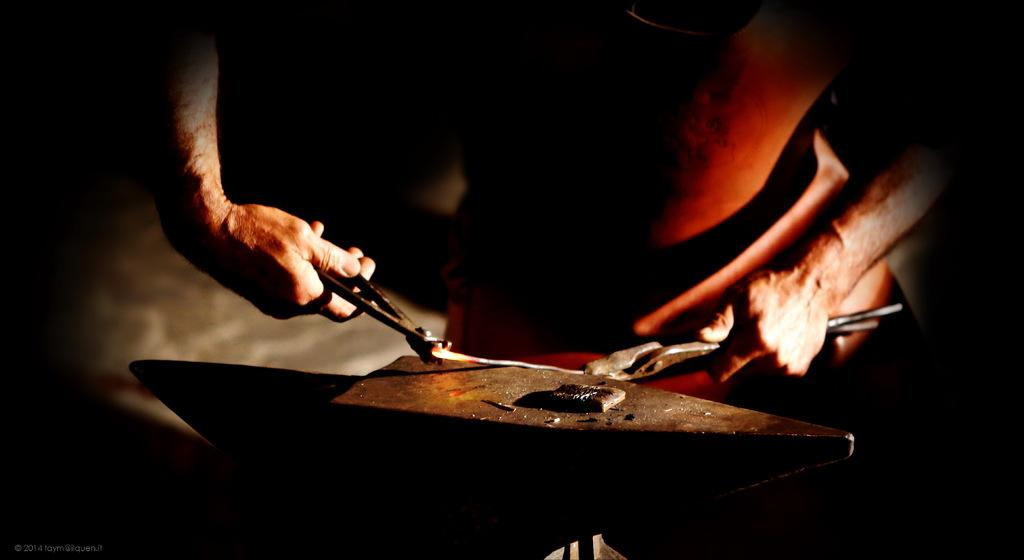Who is present in the image? There is a man in the image. What is the man holding in his hands? The man is holding metal tools in his hands. What can be seen at the bottom of the image? There is a metal object at the bottom of the image. Can you see a lake in the background of the image? There is no lake present in the image. What type of face is visible on the man's shirt in the image? The man's shirt is not visible in the image, so it is not possible to determine if there is a face on it. 